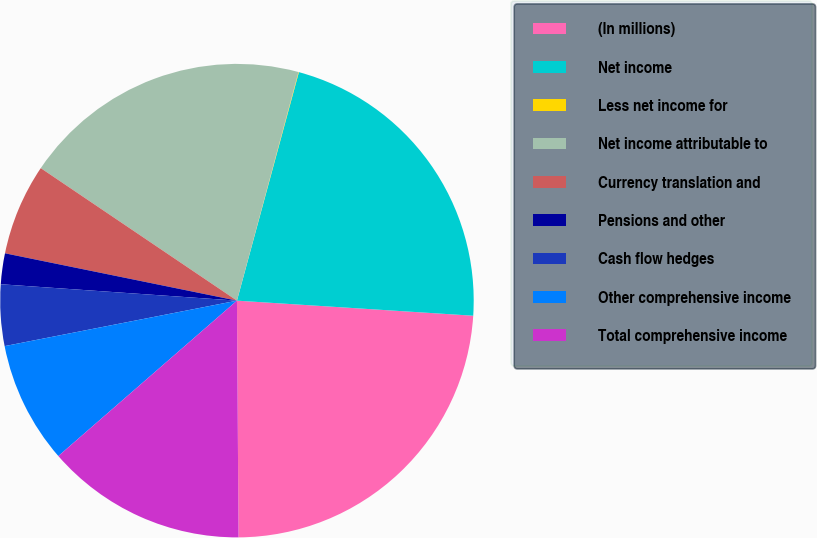Convert chart to OTSL. <chart><loc_0><loc_0><loc_500><loc_500><pie_chart><fcel>(In millions)<fcel>Net income<fcel>Less net income for<fcel>Net income attributable to<fcel>Currency translation and<fcel>Pensions and other<fcel>Cash flow hedges<fcel>Other comprehensive income<fcel>Total comprehensive income<nl><fcel>23.88%<fcel>21.8%<fcel>0.03%<fcel>19.73%<fcel>6.25%<fcel>2.1%<fcel>4.18%<fcel>8.32%<fcel>13.71%<nl></chart> 